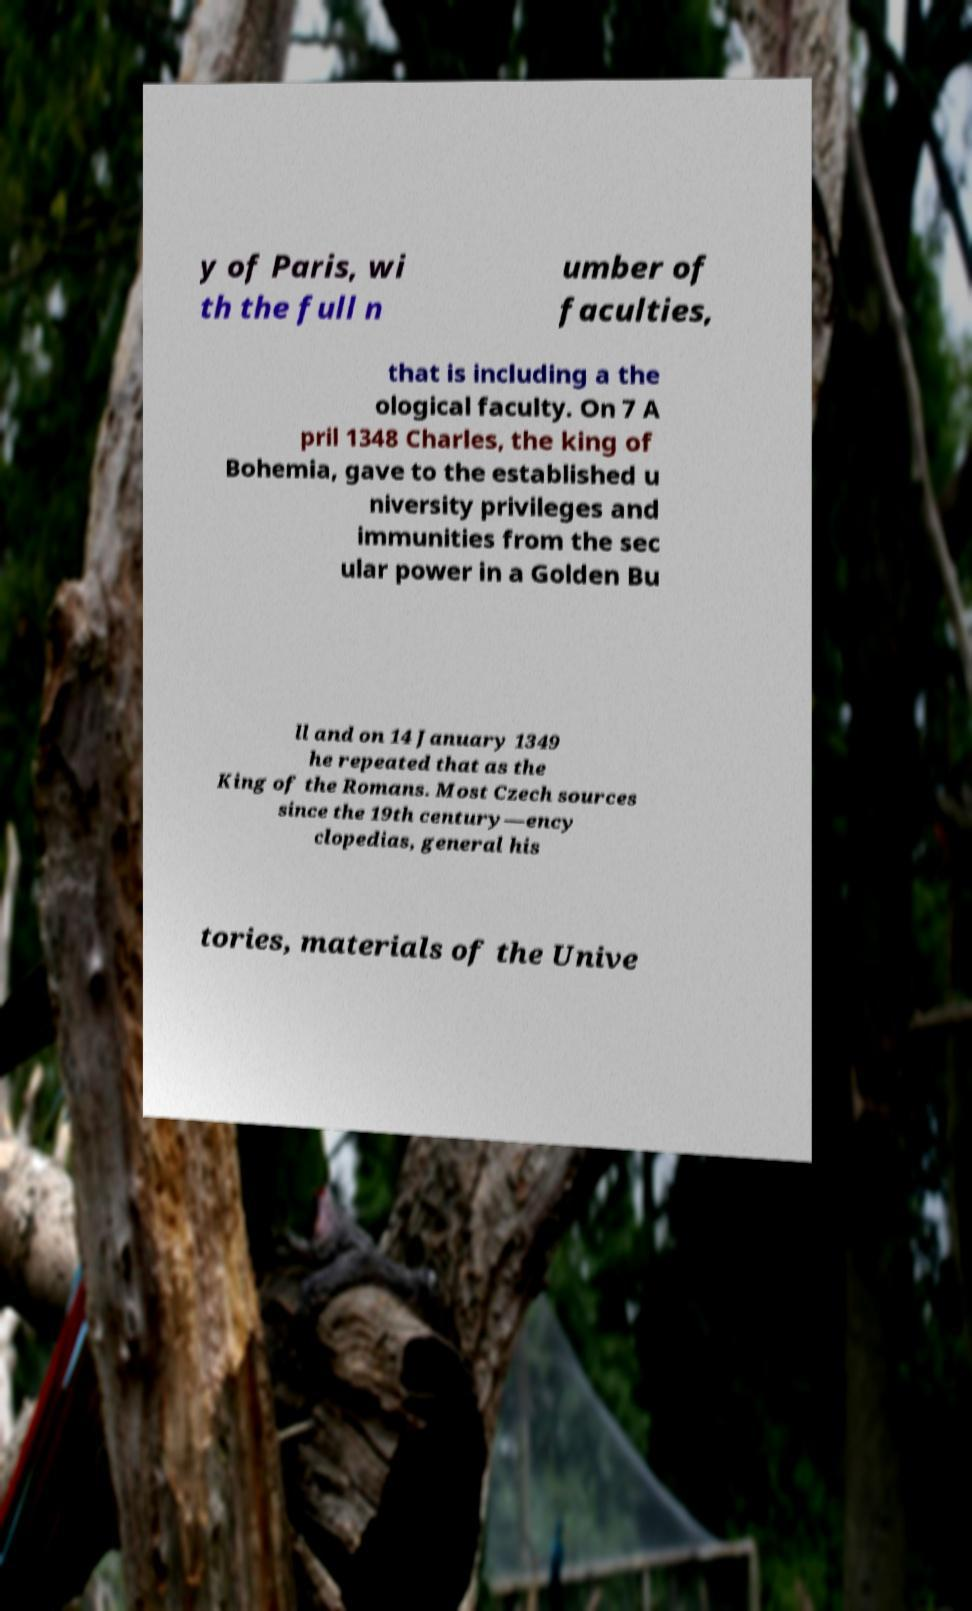Please read and relay the text visible in this image. What does it say? y of Paris, wi th the full n umber of faculties, that is including a the ological faculty. On 7 A pril 1348 Charles, the king of Bohemia, gave to the established u niversity privileges and immunities from the sec ular power in a Golden Bu ll and on 14 January 1349 he repeated that as the King of the Romans. Most Czech sources since the 19th century—ency clopedias, general his tories, materials of the Unive 